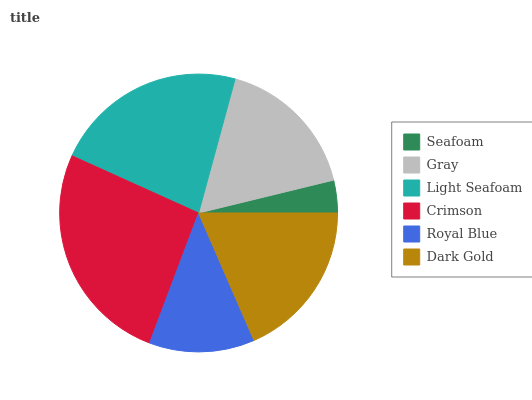Is Seafoam the minimum?
Answer yes or no. Yes. Is Crimson the maximum?
Answer yes or no. Yes. Is Gray the minimum?
Answer yes or no. No. Is Gray the maximum?
Answer yes or no. No. Is Gray greater than Seafoam?
Answer yes or no. Yes. Is Seafoam less than Gray?
Answer yes or no. Yes. Is Seafoam greater than Gray?
Answer yes or no. No. Is Gray less than Seafoam?
Answer yes or no. No. Is Dark Gold the high median?
Answer yes or no. Yes. Is Gray the low median?
Answer yes or no. Yes. Is Light Seafoam the high median?
Answer yes or no. No. Is Seafoam the low median?
Answer yes or no. No. 